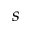<formula> <loc_0><loc_0><loc_500><loc_500>s</formula> 